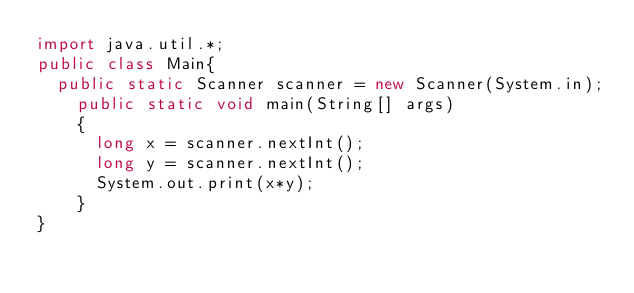<code> <loc_0><loc_0><loc_500><loc_500><_Java_>import java.util.*;
public class Main{
	public static Scanner scanner = new Scanner(System.in);
  	public static void main(String[] args)
    {
      long x = scanner.nextInt();
      long y = scanner.nextInt();
      System.out.print(x*y);
    }
}</code> 